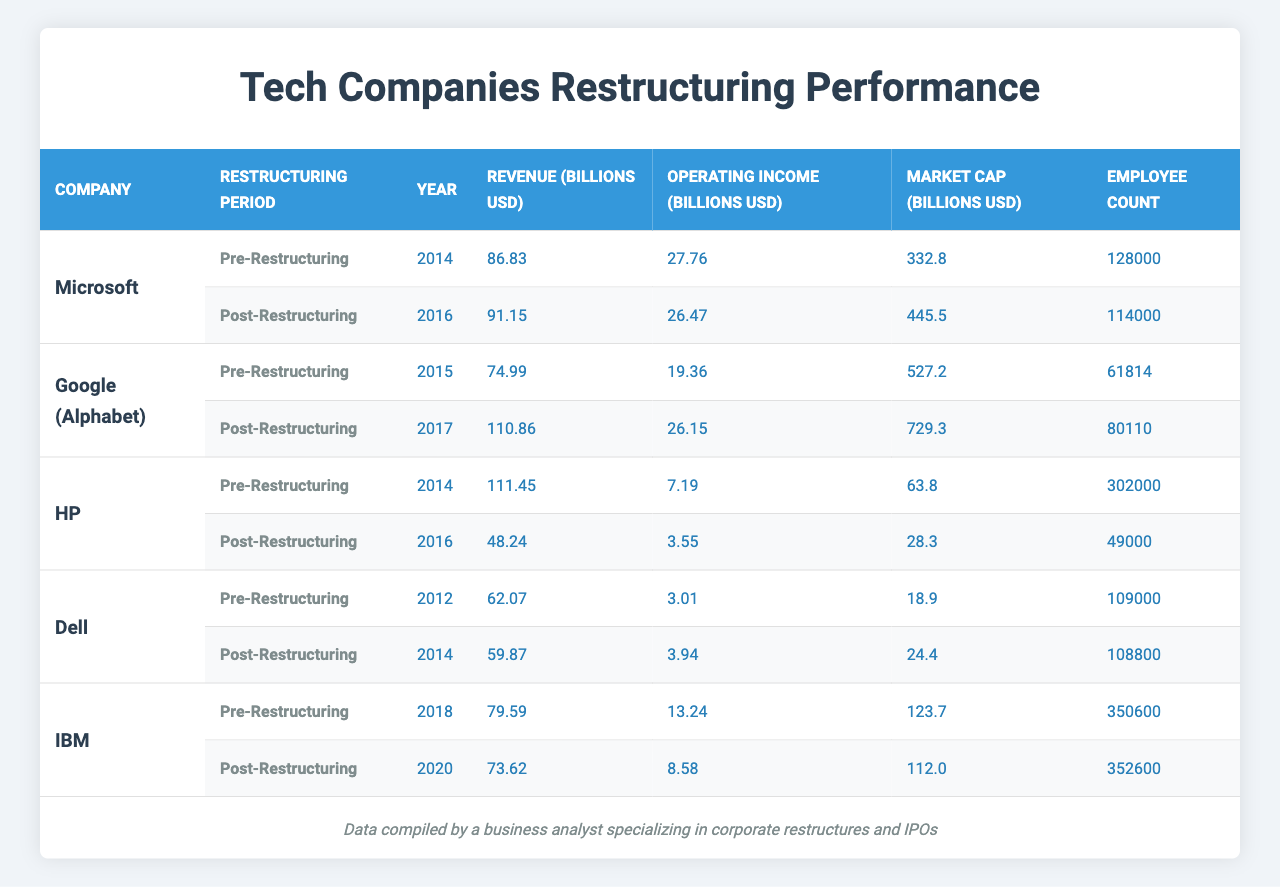What was Microsoft's revenue in 2014? The table shows Microsoft had a revenue of 86.83 billion USD in the year 2014 under the Pre-Restructuring section.
Answer: 86.83 billion USD What was Google's operating income after restructuring in 2017? According to the table, Google's operating income in the Post-Restructuring section for the year 2017 was 26.15 billion USD.
Answer: 26.15 billion USD Did HP's employee count increase or decrease after restructuring? The table indicates HP had 302,000 employees before restructuring in 2014 and 49,000 employees after restructuring in 2016, showing a decrease.
Answer: Decrease What is the difference in market cap for Dell before and after restructuring? The table lists Dell's market cap as 18.9 billion USD before restructuring in 2012 and 24.4 billion USD after restructuring in 2014. The difference is calculated as 24.4 - 18.9 = 5.5 billion USD.
Answer: 5.5 billion USD Which company had the highest revenue in the Post-Restructuring period? By comparing the Post-Restructuring revenues, Google's 110.86 billion USD in 2017 is the highest among all companies listed, including Microsoft, HP, Dell, and IBM.
Answer: Google What was the average operating income of the companies in the Pre-Restructuring phase? The operating incomes are: Microsoft (27.76), Google (19.36), HP (7.19), Dell (3.01), IBM (13.24). Summing these gives 70.56 billion USD, and with 5 companies, the average is calculated as 70.56 / 5 = 14.112 billion USD.
Answer: 14.112 billion USD Did any company experience a decrease in revenue after restructuring? Looking at the revenue changes in the table, HP saw a decrease from 111.45 billion USD before restructuring to 48.24 billion USD after restructuring, confirming a decline.
Answer: Yes What was the change in employee count for IBM between 2018 and 2020? The table states that IBM had 350,600 employees in 2018 and had 352,600 employees in 2020, indicating an increase of 2,000 employees after restructuring.
Answer: Increase by 2,000 employees Which company's market cap grew the most after restructuring? By checking the market cap before and after restructuring, Microsoft had a growth of 112.7 billion USD (from 332.8 to 445.5 billion USD), while Google and others had lesser growths. Therefore, Microsoft experienced the most significant increase.
Answer: Microsoft What were the combined revenues of all companies Post-Restructuring? Post-Restructuring revenues are: Microsoft (91.15), Google (110.86), HP (48.24), Dell (59.87), and IBM (73.62). Adding these gives a total of 91.15 + 110.86 + 48.24 + 59.87 + 73.62 = 383.74 billion USD.
Answer: 383.74 billion USD 